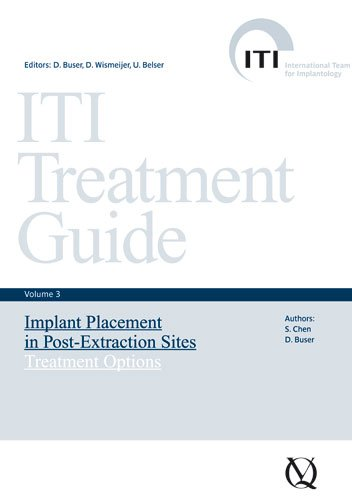Is this a pharmaceutical book? While it discusses medical procedures, it's specifically a guide on dental implant practices rather than a pharmaceutical manual. It's tailored for dental professionals dealing with implant surgeries. 